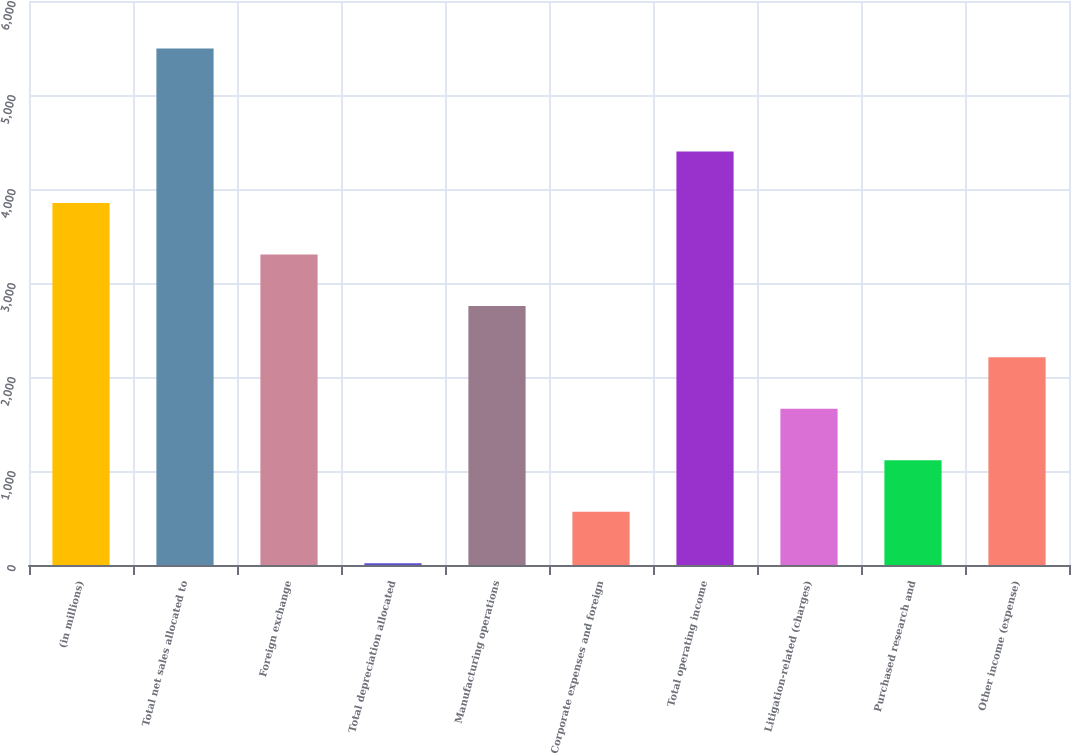Convert chart to OTSL. <chart><loc_0><loc_0><loc_500><loc_500><bar_chart><fcel>(in millions)<fcel>Total net sales allocated to<fcel>Foreign exchange<fcel>Total depreciation allocated<fcel>Manufacturing operations<fcel>Corporate expenses and foreign<fcel>Total operating income<fcel>Litigation-related (charges)<fcel>Purchased research and<fcel>Other income (expense)<nl><fcel>3851.5<fcel>5494<fcel>3304<fcel>19<fcel>2756.5<fcel>566.5<fcel>4399<fcel>1661.5<fcel>1114<fcel>2209<nl></chart> 